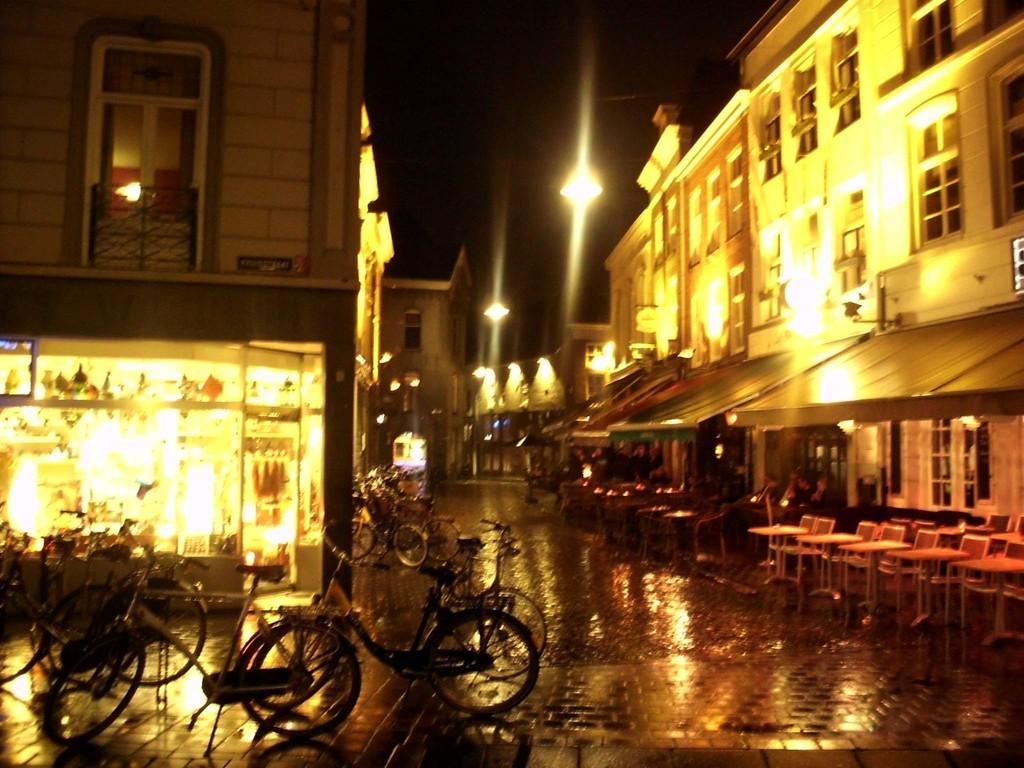What type of structures can be seen in the image? There are buildings in the image. What can be observed illuminating the scene in the image? There are lights in the image. What type of furniture is present on the side in the image? There are chairs and tables on the side in the image. What mode of transportation can be seen parked in the image? There are bicycles parked in the image. What type of stem is used to hold the bicycles in the image? There is no stem present in the image; the bicycles are parked on the ground. 